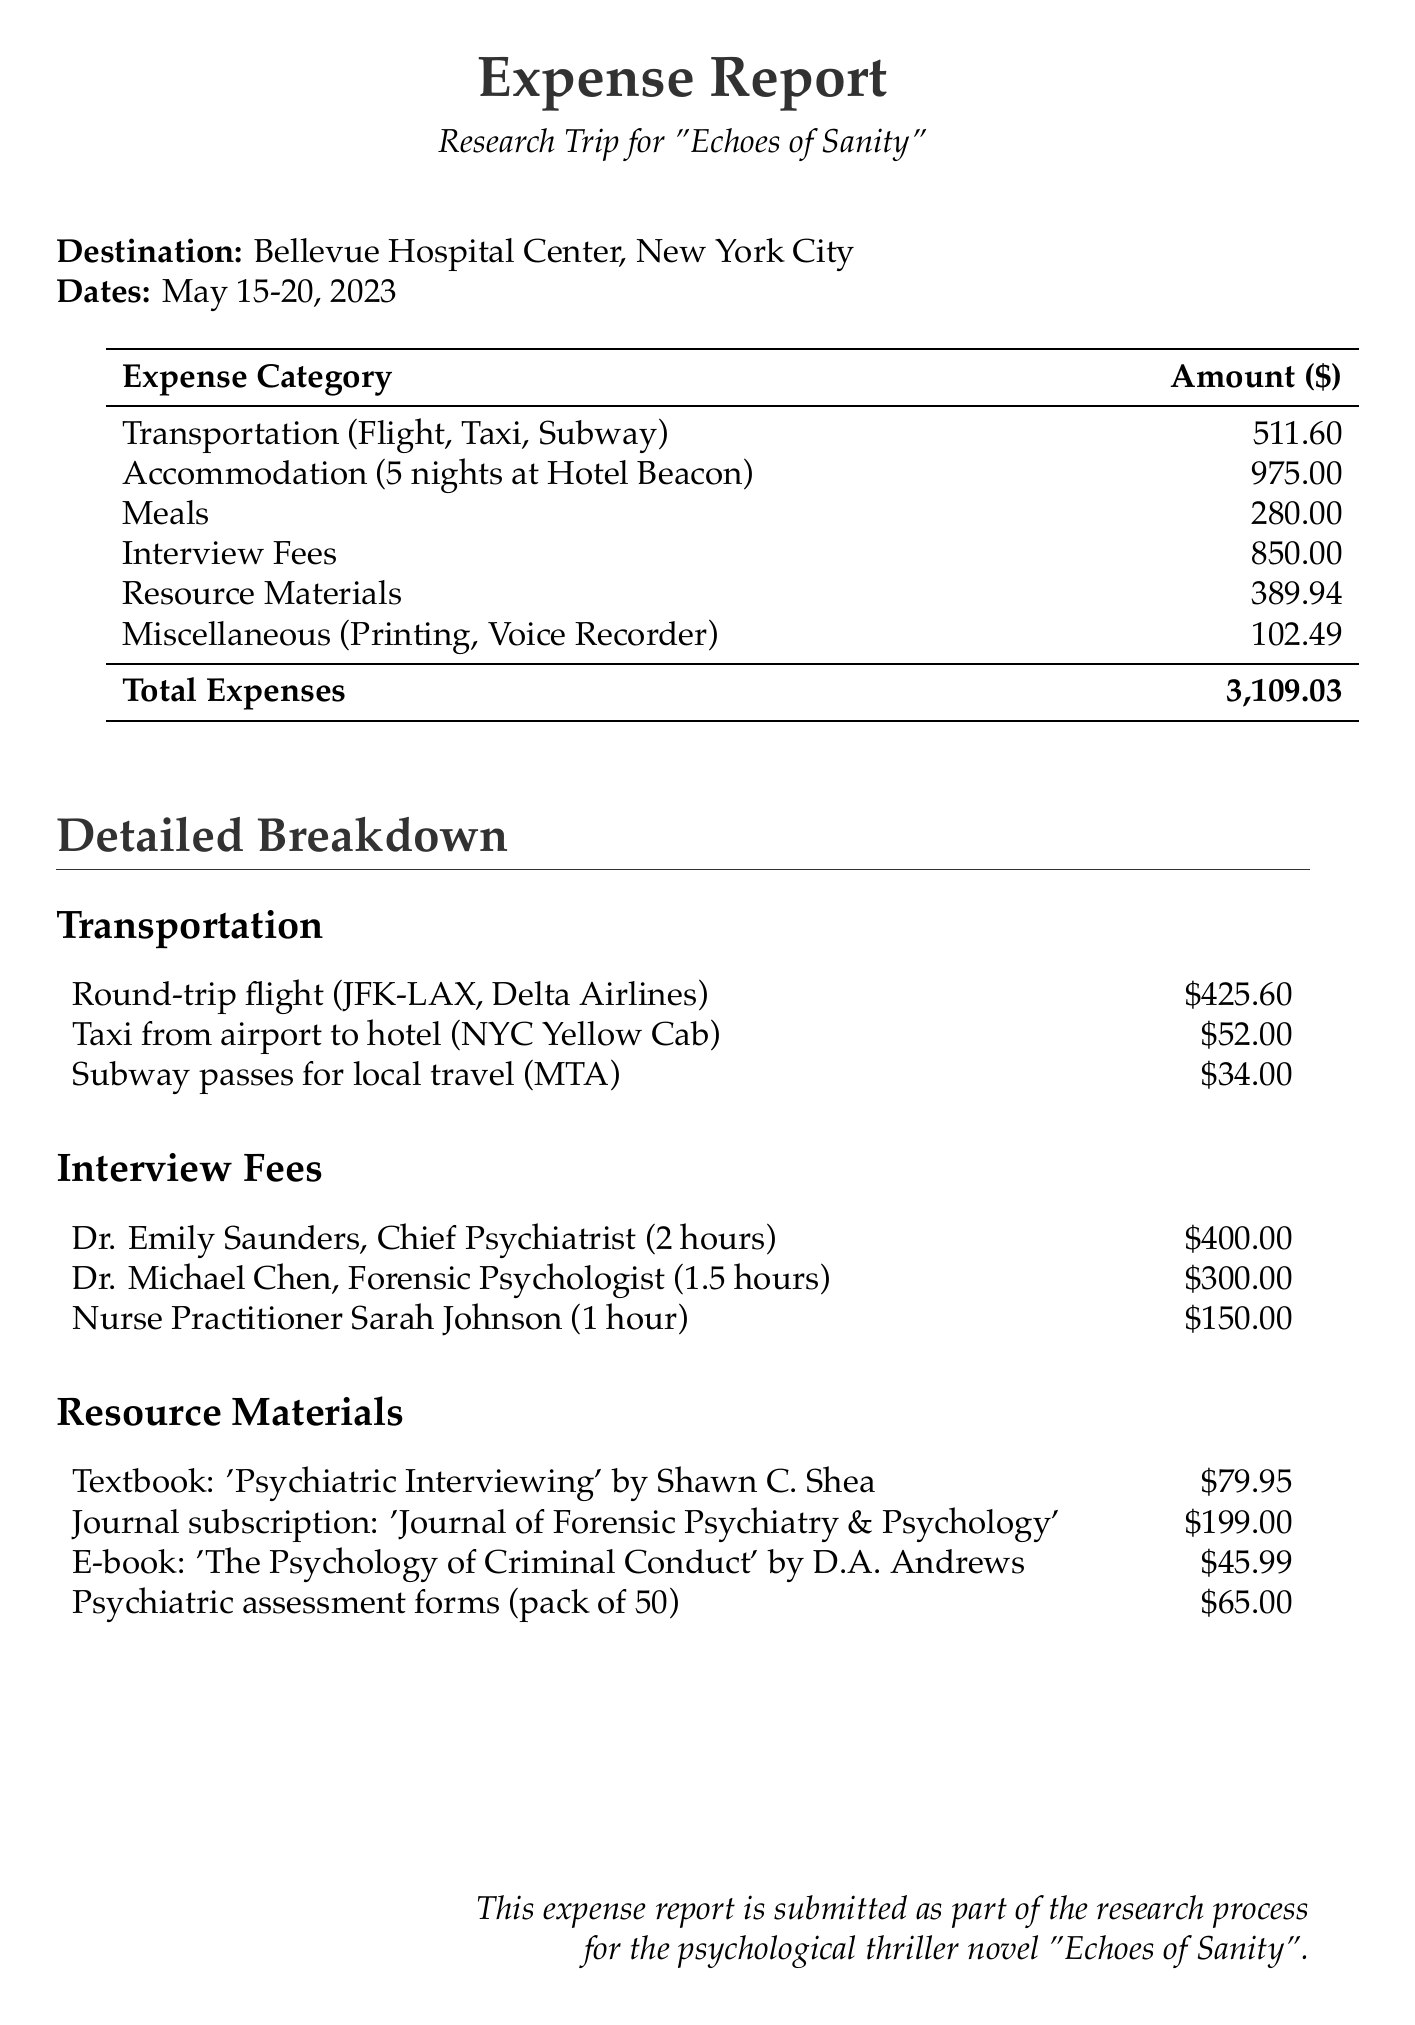What is the total expenses amount? The total expenses amount is listed in the document as the sum of all categorized costs.
Answer: 3,109.03 What is the purpose of the trip? The trip's purpose is specified at the beginning of the document.
Answer: Research for psychological thriller novel 'Echoes of Sanity' Which psychiatric facility was visited? The name of the facility is mentioned in the document.
Answer: Bellevue Hospital Center, New York City How many nights was accommodation booked for? The duration of the accommodation is detailed in the accommodation section.
Answer: 5 nights What was the cost of the interviews with Dr. Michael Chen? The cost for the interview with Dr. Michael Chen is specifically listed in the interview fees section.
Answer: 300.00 What is the duration of the interview with nurse practitioner Sarah Johnson? The duration of Sarah Johnson's interview is stated alongside her fee.
Answer: 1 hour How much was spent on transportation? The total amount spent on transportation is summarized in the expenses section of the document.
Answer: 511.60 What was the cost of the textbook 'Psychiatric Interviewing'? The cost of the textbook is detailed in the resource materials section.
Answer: 79.95 Who published the journal subscription mentioned in the report? The publisher of the journal subscription is specified in the resource materials section.
Answer: Taylor & Francis 